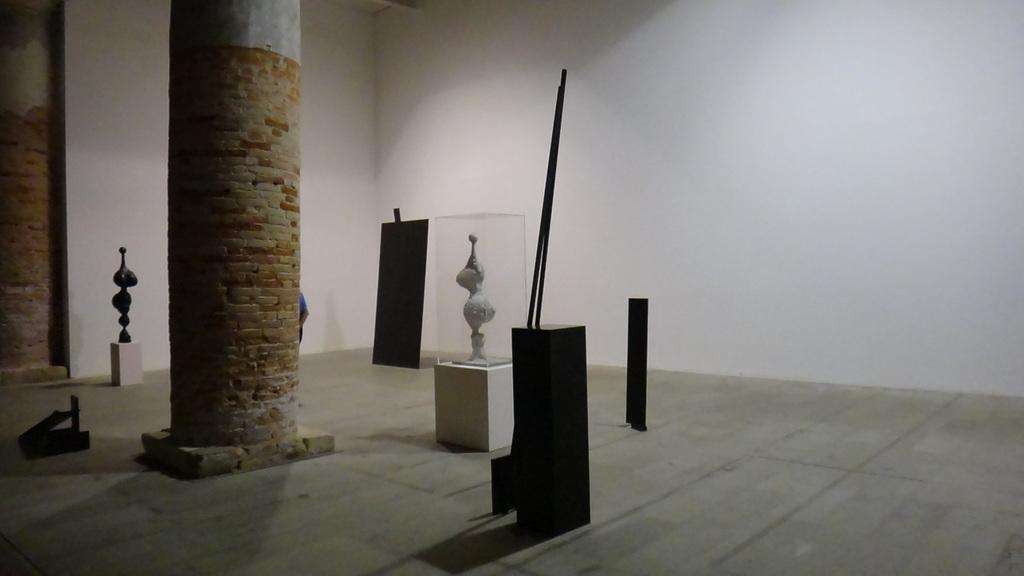What type of structure is visible in the image? There is a hall in the image. Can you describe any architectural features of the hall? The hall has two pillars. What is located near the hall? There are stones near the hall. What is placed on the stones? There are objects placed on the stones. What organization is responsible for the motion of the stones in the image? There is no motion of the stones in the image, and no organization is mentioned or implied. 